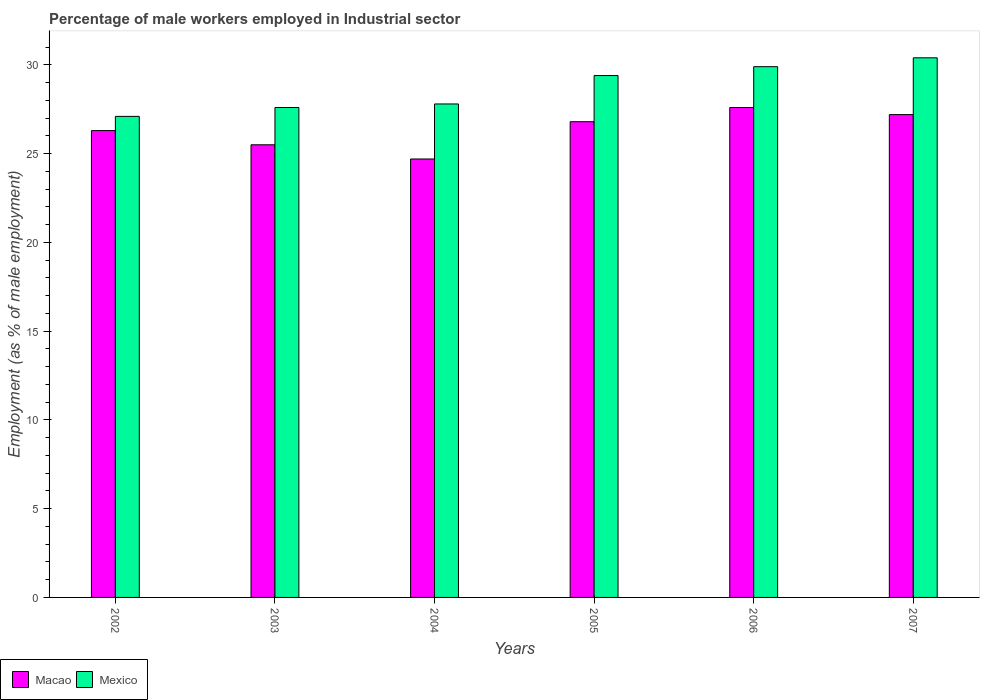How many groups of bars are there?
Your answer should be compact. 6. Are the number of bars per tick equal to the number of legend labels?
Provide a short and direct response. Yes. Are the number of bars on each tick of the X-axis equal?
Make the answer very short. Yes. How many bars are there on the 3rd tick from the left?
Your response must be concise. 2. How many bars are there on the 4th tick from the right?
Keep it short and to the point. 2. What is the percentage of male workers employed in Industrial sector in Mexico in 2004?
Make the answer very short. 27.8. Across all years, what is the maximum percentage of male workers employed in Industrial sector in Macao?
Provide a short and direct response. 27.6. Across all years, what is the minimum percentage of male workers employed in Industrial sector in Mexico?
Keep it short and to the point. 27.1. In which year was the percentage of male workers employed in Industrial sector in Mexico minimum?
Ensure brevity in your answer.  2002. What is the total percentage of male workers employed in Industrial sector in Mexico in the graph?
Give a very brief answer. 172.2. What is the difference between the percentage of male workers employed in Industrial sector in Mexico in 2006 and that in 2007?
Your response must be concise. -0.5. What is the average percentage of male workers employed in Industrial sector in Macao per year?
Provide a succinct answer. 26.35. In the year 2003, what is the difference between the percentage of male workers employed in Industrial sector in Mexico and percentage of male workers employed in Industrial sector in Macao?
Your response must be concise. 2.1. In how many years, is the percentage of male workers employed in Industrial sector in Mexico greater than 11 %?
Offer a terse response. 6. What is the ratio of the percentage of male workers employed in Industrial sector in Macao in 2003 to that in 2005?
Provide a succinct answer. 0.95. Is the percentage of male workers employed in Industrial sector in Mexico in 2002 less than that in 2007?
Your answer should be compact. Yes. Is the difference between the percentage of male workers employed in Industrial sector in Mexico in 2004 and 2007 greater than the difference between the percentage of male workers employed in Industrial sector in Macao in 2004 and 2007?
Provide a succinct answer. No. What is the difference between the highest and the second highest percentage of male workers employed in Industrial sector in Mexico?
Offer a very short reply. 0.5. What is the difference between the highest and the lowest percentage of male workers employed in Industrial sector in Macao?
Your answer should be compact. 2.9. In how many years, is the percentage of male workers employed in Industrial sector in Mexico greater than the average percentage of male workers employed in Industrial sector in Mexico taken over all years?
Provide a short and direct response. 3. What does the 1st bar from the left in 2005 represents?
Provide a short and direct response. Macao. What does the 2nd bar from the right in 2003 represents?
Provide a short and direct response. Macao. Are all the bars in the graph horizontal?
Your response must be concise. No. What is the difference between two consecutive major ticks on the Y-axis?
Your answer should be very brief. 5. Are the values on the major ticks of Y-axis written in scientific E-notation?
Provide a succinct answer. No. Does the graph contain any zero values?
Give a very brief answer. No. Does the graph contain grids?
Your answer should be compact. No. What is the title of the graph?
Keep it short and to the point. Percentage of male workers employed in Industrial sector. Does "Germany" appear as one of the legend labels in the graph?
Make the answer very short. No. What is the label or title of the Y-axis?
Keep it short and to the point. Employment (as % of male employment). What is the Employment (as % of male employment) in Macao in 2002?
Provide a short and direct response. 26.3. What is the Employment (as % of male employment) in Mexico in 2002?
Offer a terse response. 27.1. What is the Employment (as % of male employment) in Mexico in 2003?
Keep it short and to the point. 27.6. What is the Employment (as % of male employment) of Macao in 2004?
Your answer should be very brief. 24.7. What is the Employment (as % of male employment) of Mexico in 2004?
Your answer should be very brief. 27.8. What is the Employment (as % of male employment) of Macao in 2005?
Provide a short and direct response. 26.8. What is the Employment (as % of male employment) in Mexico in 2005?
Your response must be concise. 29.4. What is the Employment (as % of male employment) in Macao in 2006?
Offer a terse response. 27.6. What is the Employment (as % of male employment) in Mexico in 2006?
Your response must be concise. 29.9. What is the Employment (as % of male employment) in Macao in 2007?
Your answer should be compact. 27.2. What is the Employment (as % of male employment) in Mexico in 2007?
Provide a short and direct response. 30.4. Across all years, what is the maximum Employment (as % of male employment) of Macao?
Make the answer very short. 27.6. Across all years, what is the maximum Employment (as % of male employment) in Mexico?
Offer a terse response. 30.4. Across all years, what is the minimum Employment (as % of male employment) in Macao?
Your response must be concise. 24.7. Across all years, what is the minimum Employment (as % of male employment) of Mexico?
Keep it short and to the point. 27.1. What is the total Employment (as % of male employment) in Macao in the graph?
Keep it short and to the point. 158.1. What is the total Employment (as % of male employment) in Mexico in the graph?
Provide a short and direct response. 172.2. What is the difference between the Employment (as % of male employment) in Mexico in 2002 and that in 2003?
Your answer should be very brief. -0.5. What is the difference between the Employment (as % of male employment) in Macao in 2002 and that in 2004?
Make the answer very short. 1.6. What is the difference between the Employment (as % of male employment) of Mexico in 2002 and that in 2004?
Provide a succinct answer. -0.7. What is the difference between the Employment (as % of male employment) in Macao in 2002 and that in 2005?
Keep it short and to the point. -0.5. What is the difference between the Employment (as % of male employment) in Macao in 2002 and that in 2006?
Provide a short and direct response. -1.3. What is the difference between the Employment (as % of male employment) of Macao in 2002 and that in 2007?
Give a very brief answer. -0.9. What is the difference between the Employment (as % of male employment) of Macao in 2003 and that in 2004?
Your answer should be very brief. 0.8. What is the difference between the Employment (as % of male employment) in Mexico in 2003 and that in 2004?
Your answer should be compact. -0.2. What is the difference between the Employment (as % of male employment) of Macao in 2003 and that in 2005?
Your response must be concise. -1.3. What is the difference between the Employment (as % of male employment) in Macao in 2003 and that in 2006?
Ensure brevity in your answer.  -2.1. What is the difference between the Employment (as % of male employment) in Macao in 2004 and that in 2005?
Provide a succinct answer. -2.1. What is the difference between the Employment (as % of male employment) of Mexico in 2004 and that in 2005?
Keep it short and to the point. -1.6. What is the difference between the Employment (as % of male employment) of Macao in 2004 and that in 2006?
Your answer should be compact. -2.9. What is the difference between the Employment (as % of male employment) of Mexico in 2004 and that in 2006?
Provide a succinct answer. -2.1. What is the difference between the Employment (as % of male employment) in Macao in 2004 and that in 2007?
Give a very brief answer. -2.5. What is the difference between the Employment (as % of male employment) in Mexico in 2005 and that in 2007?
Offer a very short reply. -1. What is the difference between the Employment (as % of male employment) in Mexico in 2006 and that in 2007?
Give a very brief answer. -0.5. What is the difference between the Employment (as % of male employment) in Macao in 2002 and the Employment (as % of male employment) in Mexico in 2003?
Offer a terse response. -1.3. What is the difference between the Employment (as % of male employment) of Macao in 2002 and the Employment (as % of male employment) of Mexico in 2006?
Ensure brevity in your answer.  -3.6. What is the difference between the Employment (as % of male employment) in Macao in 2002 and the Employment (as % of male employment) in Mexico in 2007?
Give a very brief answer. -4.1. What is the difference between the Employment (as % of male employment) in Macao in 2003 and the Employment (as % of male employment) in Mexico in 2007?
Provide a succinct answer. -4.9. What is the difference between the Employment (as % of male employment) of Macao in 2004 and the Employment (as % of male employment) of Mexico in 2006?
Ensure brevity in your answer.  -5.2. What is the difference between the Employment (as % of male employment) of Macao in 2005 and the Employment (as % of male employment) of Mexico in 2006?
Your response must be concise. -3.1. What is the difference between the Employment (as % of male employment) in Macao in 2006 and the Employment (as % of male employment) in Mexico in 2007?
Your answer should be very brief. -2.8. What is the average Employment (as % of male employment) of Macao per year?
Make the answer very short. 26.35. What is the average Employment (as % of male employment) in Mexico per year?
Give a very brief answer. 28.7. In the year 2003, what is the difference between the Employment (as % of male employment) in Macao and Employment (as % of male employment) in Mexico?
Ensure brevity in your answer.  -2.1. In the year 2004, what is the difference between the Employment (as % of male employment) in Macao and Employment (as % of male employment) in Mexico?
Offer a very short reply. -3.1. In the year 2005, what is the difference between the Employment (as % of male employment) in Macao and Employment (as % of male employment) in Mexico?
Keep it short and to the point. -2.6. In the year 2006, what is the difference between the Employment (as % of male employment) in Macao and Employment (as % of male employment) in Mexico?
Make the answer very short. -2.3. In the year 2007, what is the difference between the Employment (as % of male employment) in Macao and Employment (as % of male employment) in Mexico?
Your answer should be very brief. -3.2. What is the ratio of the Employment (as % of male employment) in Macao in 2002 to that in 2003?
Offer a very short reply. 1.03. What is the ratio of the Employment (as % of male employment) in Mexico in 2002 to that in 2003?
Your response must be concise. 0.98. What is the ratio of the Employment (as % of male employment) in Macao in 2002 to that in 2004?
Give a very brief answer. 1.06. What is the ratio of the Employment (as % of male employment) in Mexico in 2002 to that in 2004?
Provide a short and direct response. 0.97. What is the ratio of the Employment (as % of male employment) of Macao in 2002 to that in 2005?
Your answer should be very brief. 0.98. What is the ratio of the Employment (as % of male employment) of Mexico in 2002 to that in 2005?
Keep it short and to the point. 0.92. What is the ratio of the Employment (as % of male employment) of Macao in 2002 to that in 2006?
Give a very brief answer. 0.95. What is the ratio of the Employment (as % of male employment) of Mexico in 2002 to that in 2006?
Your answer should be very brief. 0.91. What is the ratio of the Employment (as % of male employment) of Macao in 2002 to that in 2007?
Keep it short and to the point. 0.97. What is the ratio of the Employment (as % of male employment) in Mexico in 2002 to that in 2007?
Provide a short and direct response. 0.89. What is the ratio of the Employment (as % of male employment) in Macao in 2003 to that in 2004?
Ensure brevity in your answer.  1.03. What is the ratio of the Employment (as % of male employment) of Mexico in 2003 to that in 2004?
Your answer should be very brief. 0.99. What is the ratio of the Employment (as % of male employment) of Macao in 2003 to that in 2005?
Offer a terse response. 0.95. What is the ratio of the Employment (as % of male employment) of Mexico in 2003 to that in 2005?
Provide a short and direct response. 0.94. What is the ratio of the Employment (as % of male employment) in Macao in 2003 to that in 2006?
Make the answer very short. 0.92. What is the ratio of the Employment (as % of male employment) of Mexico in 2003 to that in 2006?
Your answer should be very brief. 0.92. What is the ratio of the Employment (as % of male employment) of Macao in 2003 to that in 2007?
Your answer should be very brief. 0.94. What is the ratio of the Employment (as % of male employment) of Mexico in 2003 to that in 2007?
Keep it short and to the point. 0.91. What is the ratio of the Employment (as % of male employment) in Macao in 2004 to that in 2005?
Make the answer very short. 0.92. What is the ratio of the Employment (as % of male employment) in Mexico in 2004 to that in 2005?
Provide a succinct answer. 0.95. What is the ratio of the Employment (as % of male employment) in Macao in 2004 to that in 2006?
Your answer should be very brief. 0.89. What is the ratio of the Employment (as % of male employment) in Mexico in 2004 to that in 2006?
Provide a short and direct response. 0.93. What is the ratio of the Employment (as % of male employment) of Macao in 2004 to that in 2007?
Your answer should be compact. 0.91. What is the ratio of the Employment (as % of male employment) in Mexico in 2004 to that in 2007?
Keep it short and to the point. 0.91. What is the ratio of the Employment (as % of male employment) in Mexico in 2005 to that in 2006?
Provide a succinct answer. 0.98. What is the ratio of the Employment (as % of male employment) in Macao in 2005 to that in 2007?
Provide a short and direct response. 0.99. What is the ratio of the Employment (as % of male employment) of Mexico in 2005 to that in 2007?
Your answer should be compact. 0.97. What is the ratio of the Employment (as % of male employment) of Macao in 2006 to that in 2007?
Your answer should be compact. 1.01. What is the ratio of the Employment (as % of male employment) of Mexico in 2006 to that in 2007?
Provide a short and direct response. 0.98. What is the difference between the highest and the second highest Employment (as % of male employment) of Macao?
Your answer should be very brief. 0.4. What is the difference between the highest and the lowest Employment (as % of male employment) of Macao?
Give a very brief answer. 2.9. What is the difference between the highest and the lowest Employment (as % of male employment) in Mexico?
Offer a terse response. 3.3. 